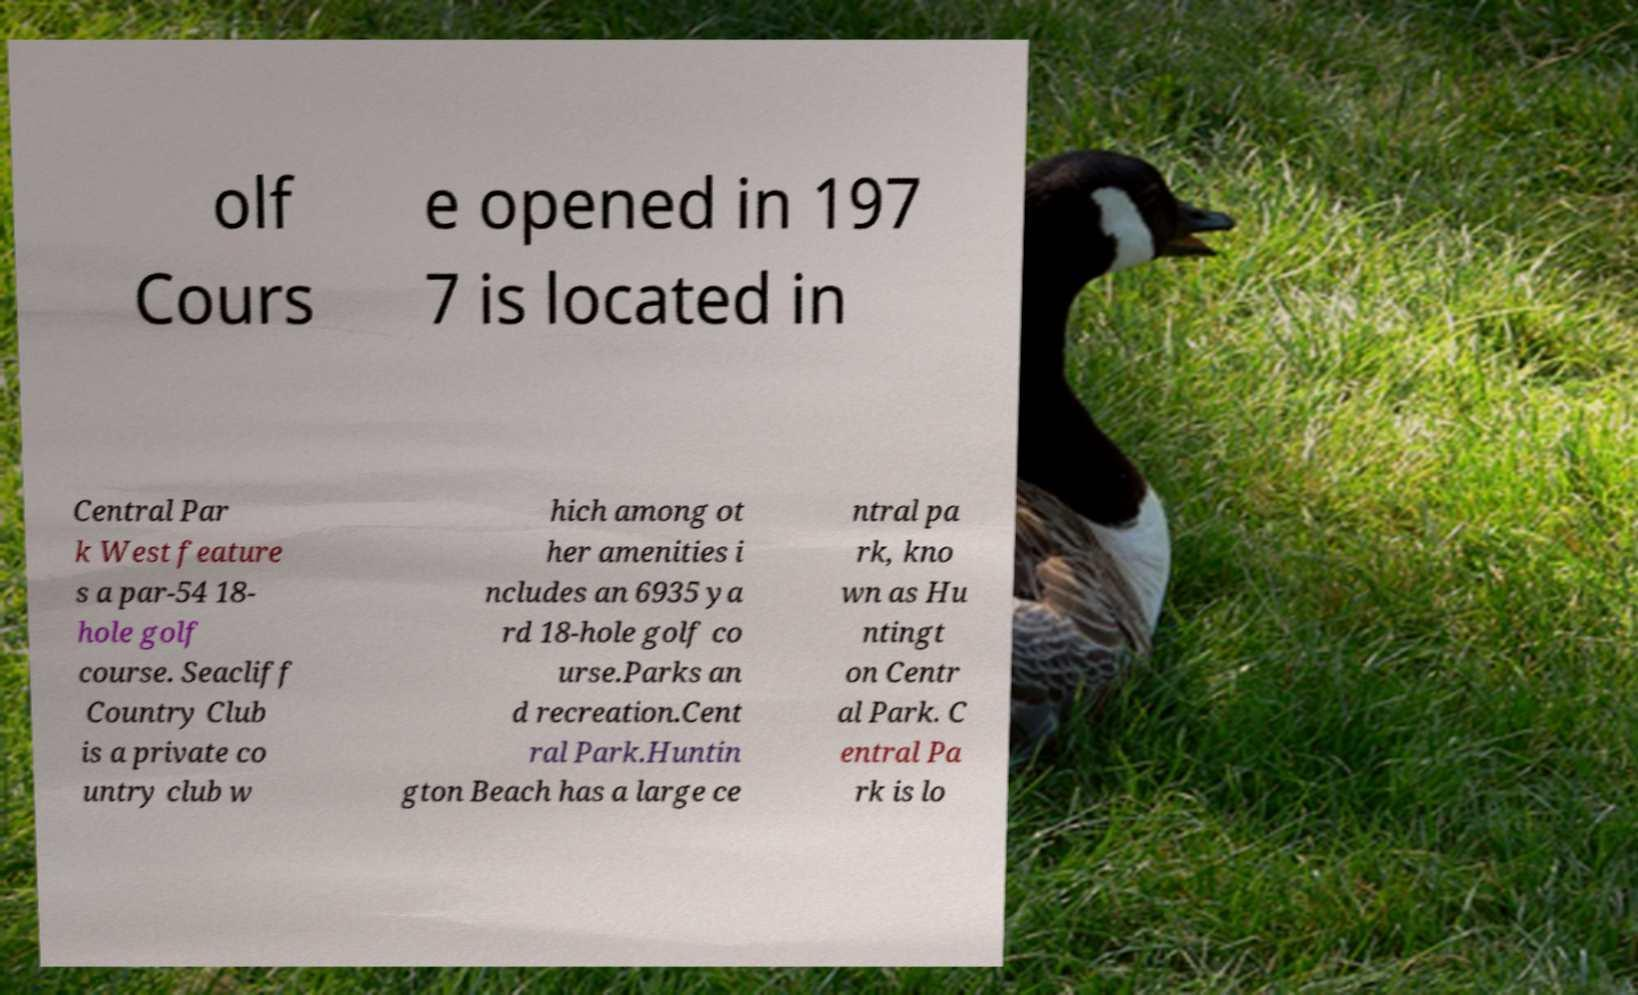Please read and relay the text visible in this image. What does it say? olf Cours e opened in 197 7 is located in Central Par k West feature s a par-54 18- hole golf course. Seacliff Country Club is a private co untry club w hich among ot her amenities i ncludes an 6935 ya rd 18-hole golf co urse.Parks an d recreation.Cent ral Park.Huntin gton Beach has a large ce ntral pa rk, kno wn as Hu ntingt on Centr al Park. C entral Pa rk is lo 